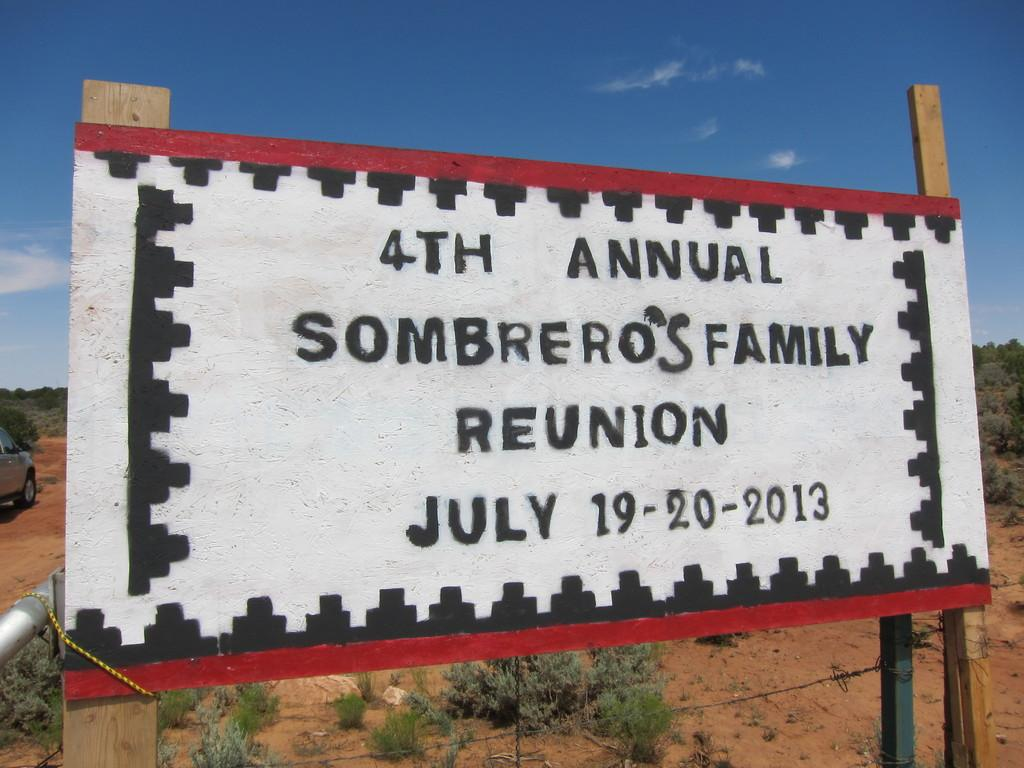<image>
Describe the image concisely. A handmade sign advertises a fourth annual family reunion. 